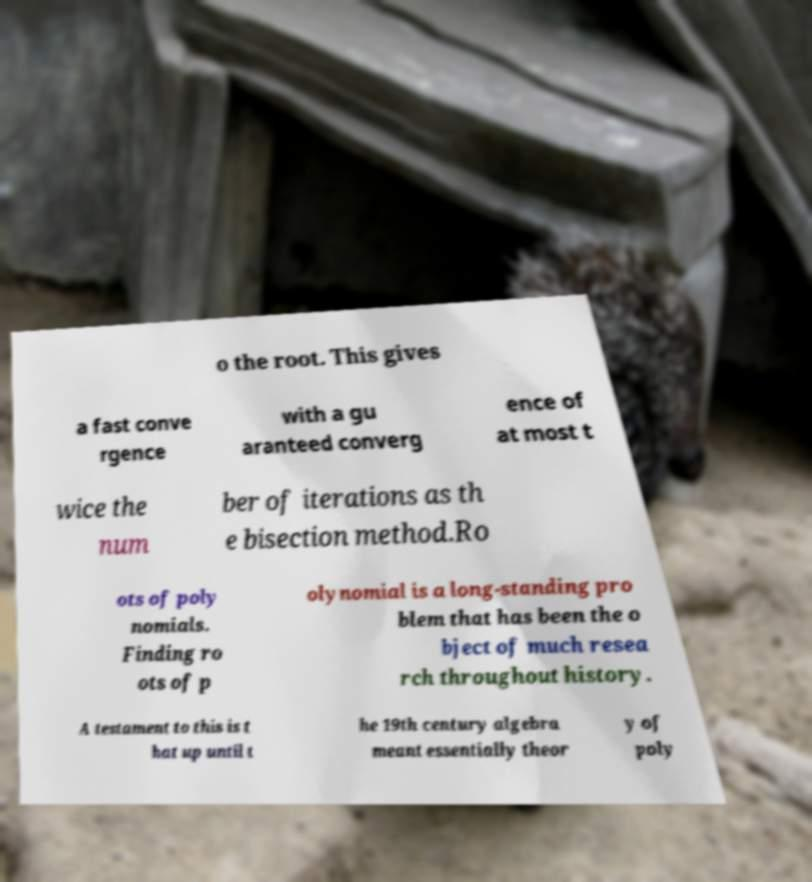There's text embedded in this image that I need extracted. Can you transcribe it verbatim? o the root. This gives a fast conve rgence with a gu aranteed converg ence of at most t wice the num ber of iterations as th e bisection method.Ro ots of poly nomials. Finding ro ots of p olynomial is a long-standing pro blem that has been the o bject of much resea rch throughout history. A testament to this is t hat up until t he 19th century algebra meant essentially theor y of poly 